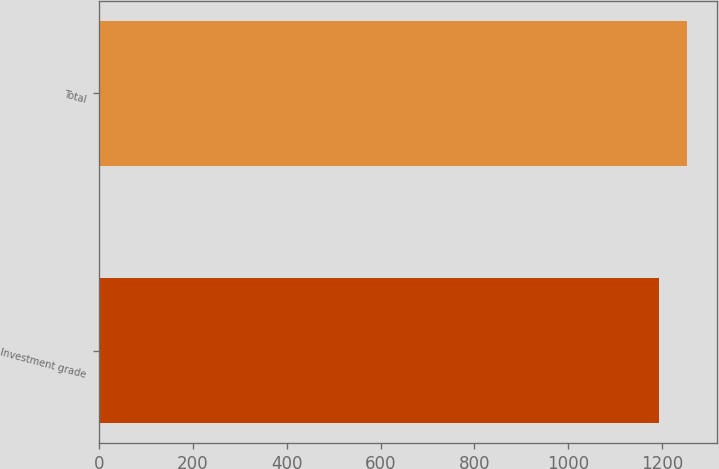Convert chart to OTSL. <chart><loc_0><loc_0><loc_500><loc_500><bar_chart><fcel>Investment grade<fcel>Total<nl><fcel>1194<fcel>1254<nl></chart> 